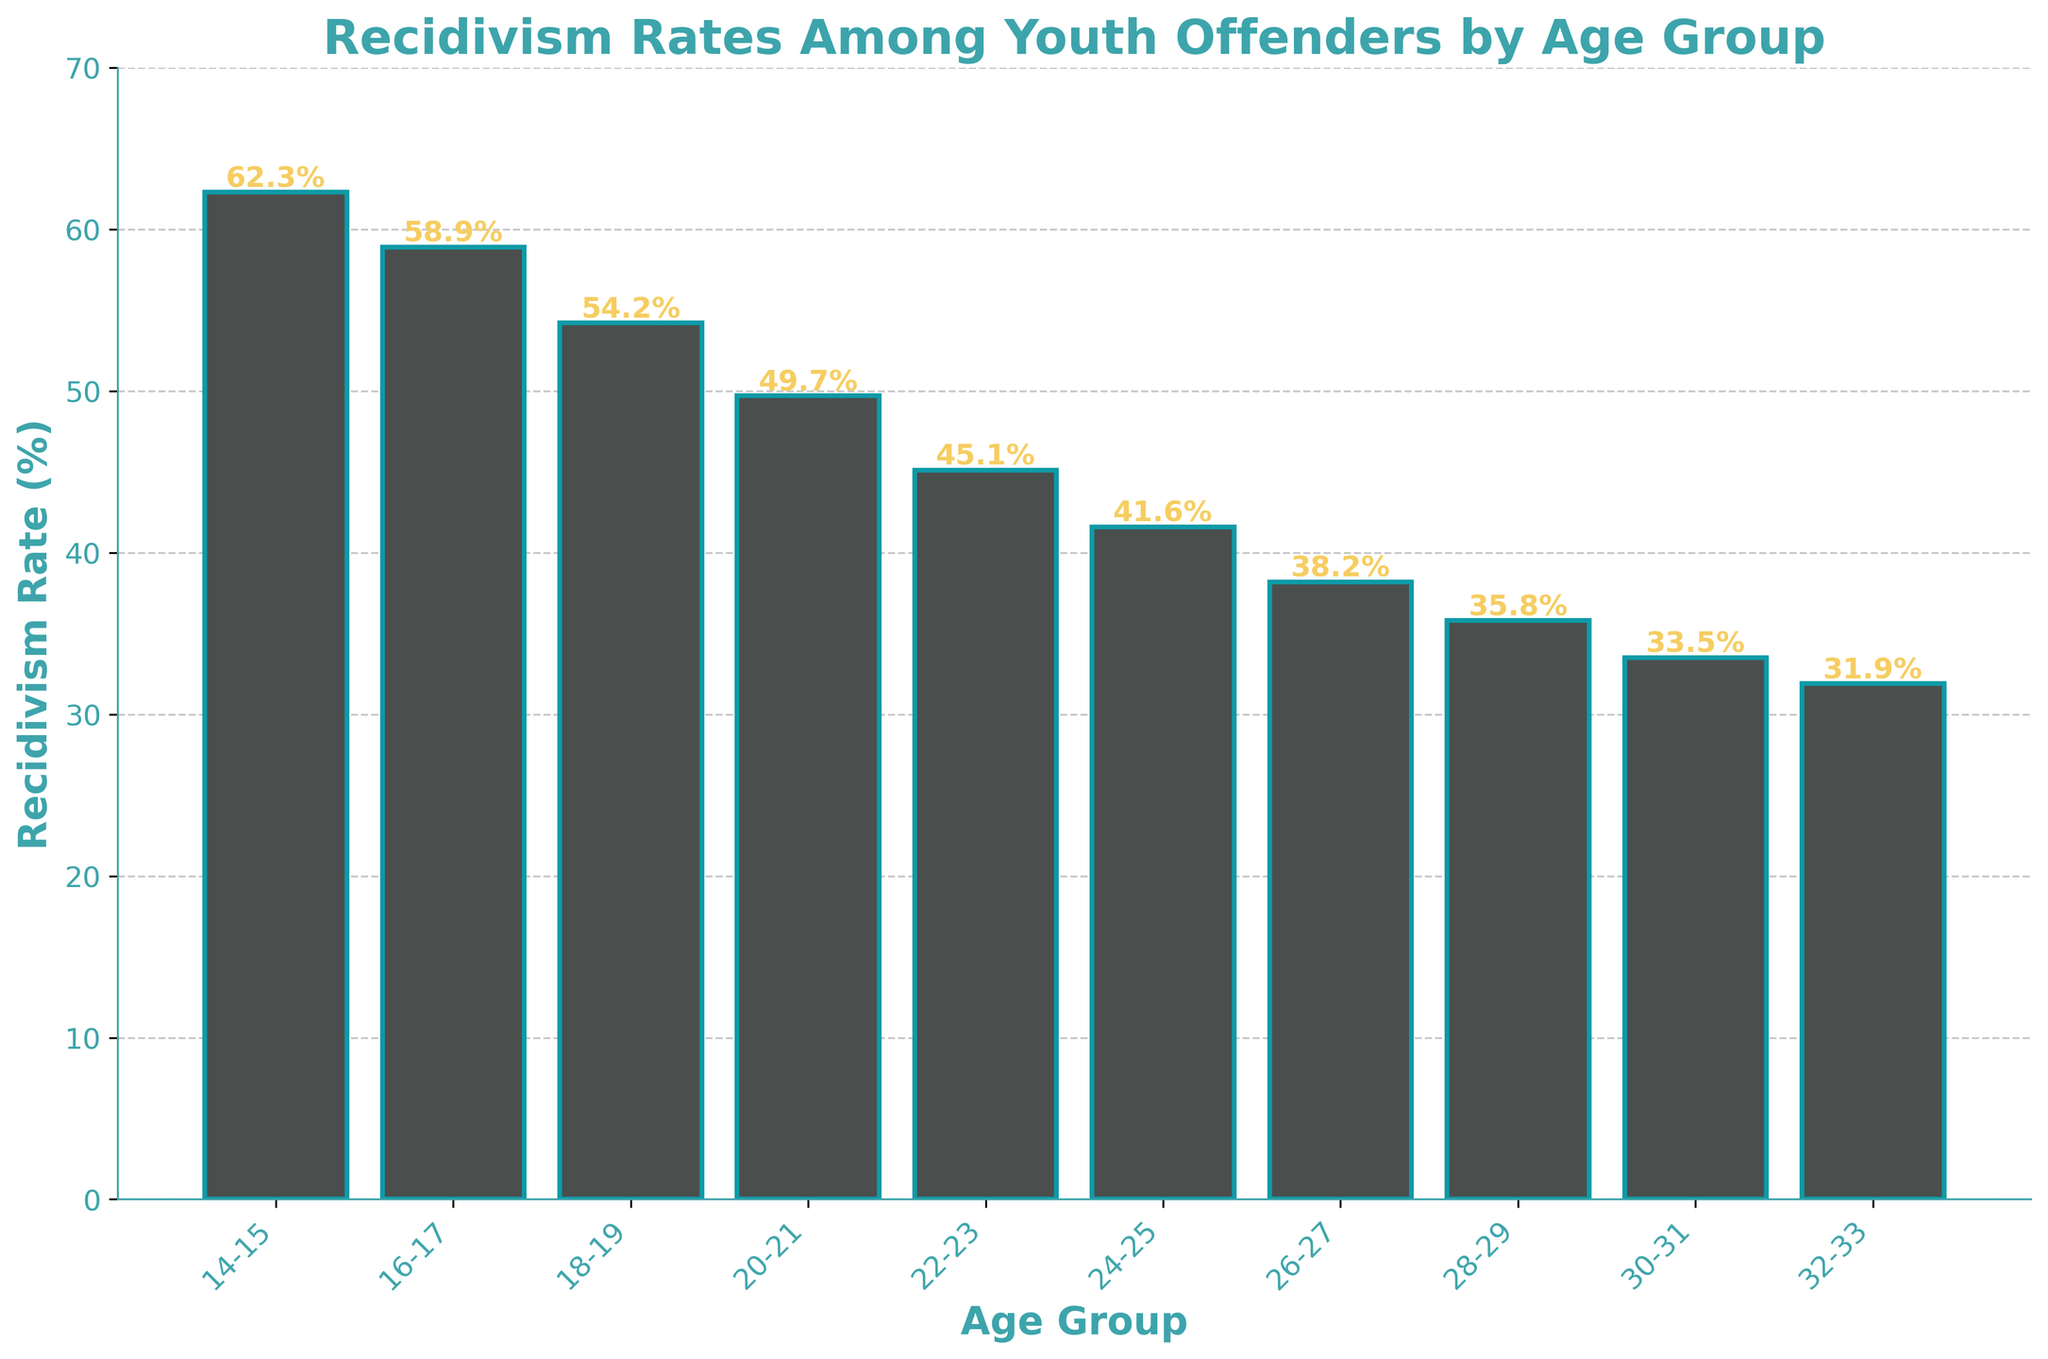What's the age group with the highest recidivism rate? The age group with the highest bar indicates the highest recidivism rate, which is the 14-15 age group at 62.3%.
Answer: 14-15 Which age group has the lowest recidivism rate? The age group with the lowest bar represents the lowest recidivism rate, which is the 32-33 age group at 31.9%.
Answer: 32-33 What's the combined recidivism rate for the 18-19 and 20-21 age groups? The recidivism rates for 18-19 and 20-21 are 54.2% and 49.7%, respectively. Adding these gives 54.2 + 49.7 = 103.9%.
Answer: 103.9% How much greater is the recidivism rate for the 14-15 age group compared to the 22-23 age group? The recidivism rate for 14-15 is 62.3%, and for 22-23, it is 45.1%. The difference is 62.3 - 45.1 = 17.2%.
Answer: 17.2% Which age groups have a recidivism rate of over 50%? Age groups with bars extending above the 50% mark are 14-15, 16-17, and 18-19.
Answer: 14-15, 16-17, 18-19 What is the average recidivism rate for the age groups 24-25, 26-27, and 28-29? The recidivism rates for these age groups are 41.6%, 38.2%, and 35.8%, respectively. The average is (41.6 + 38.2 + 35.8) / 3 = 115.6 / 3 = 38.53%.
Answer: 38.53% By how much does the recidivism rate decline between each consecutive age group from 16-17 to 20-21? The rates are: 16-17 (58.9%), 18-19 (54.2%), 20-21 (49.7%). The differences are 58.9 - 54.2 = 4.7%, 54.2 - 49.7 = 4.5%.
Answer: 4.7%, 4.5% Which age group shows the smallest decline in recidivism rate compared to its previous age group? The smallest decline is observed between age groups 28-29 (35.8%) and 30-31 (33.5%), with a difference of 35.8 - 33.5 = 2.3%.
Answer: 28-29 to 30-31 What is the total decrease in recidivism rate from the 14-15 age group to the 28-29 age group? The recidivism rate decreases from 62.3% (14-15) to 35.8% (28-29). The total decrease is 62.3 - 35.8 = 26.5%.
Answer: 26.5% Which age range has the steepest drop in recidivism rate overall? The steepest drop occurs between age groups 20-21 (49.7%) and 22-23 (45.1%), with a difference of 49.7 - 45.1 = 4.6%.
Answer: 20-21 to 22-23 